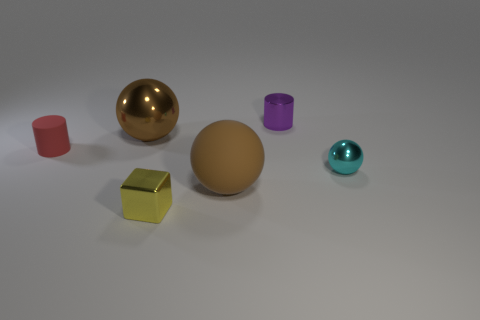Subtract all brown matte balls. How many balls are left? 2 Add 1 large brown metal spheres. How many objects exist? 7 Subtract all cyan spheres. How many spheres are left? 2 Subtract all cubes. How many objects are left? 5 Subtract 3 balls. How many balls are left? 0 Subtract all yellow spheres. Subtract all red cubes. How many spheres are left? 3 Subtract all yellow cubes. How many brown balls are left? 2 Subtract all yellow rubber objects. Subtract all purple cylinders. How many objects are left? 5 Add 6 tiny yellow cubes. How many tiny yellow cubes are left? 7 Add 2 large green blocks. How many large green blocks exist? 2 